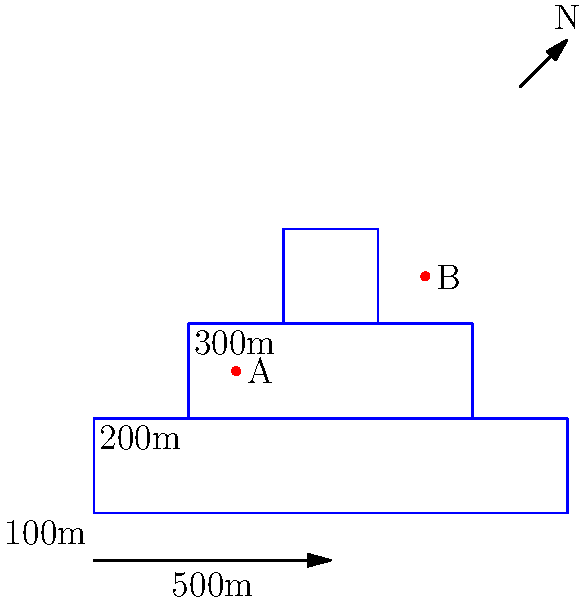Using the topographic map provided, determine the approximate elevation difference between points A and B. To find the elevation difference between points A and B, we need to follow these steps:

1. Identify the contour lines: The map shows three contour lines representing different elevations.

2. Determine the contour interval: The elevation increases by 100m between each contour line (100m, 200m, 300m).

3. Locate point A: Point A is between the 200m and 300m contour lines, closer to the 200m line.

4. Estimate elevation of point A: Since A is about 1/3 of the way between 200m and 300m, we can estimate its elevation as:
   $200m + (1/3 * 100m) \approx 233m$

5. Locate point B: Point B is just outside the 300m contour line.

6. Estimate elevation of point B: B is slightly higher than 300m, so we can estimate its elevation as approximately 310m.

7. Calculate the difference: 
   Elevation difference = Elevation of B - Elevation of A
   $\approx 310m - 233m = 77m$
Answer: Approximately 77 meters 